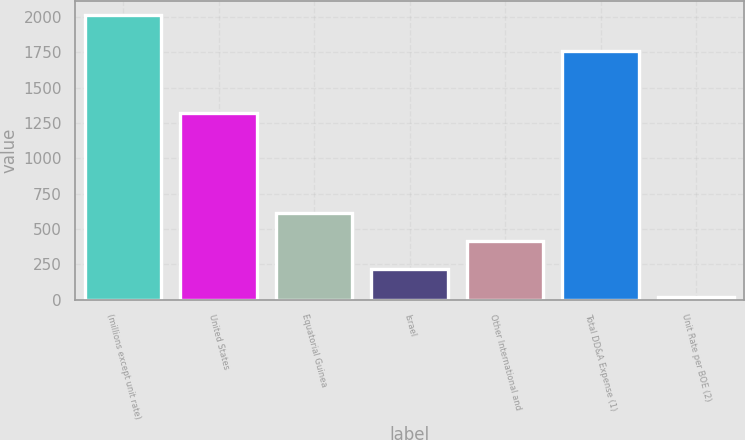<chart> <loc_0><loc_0><loc_500><loc_500><bar_chart><fcel>(millions except unit rate)<fcel>United States<fcel>Equatorial Guinea<fcel>Israel<fcel>Other International and<fcel>Total DD&A Expense (1)<fcel>Unit Rate per BOE (2)<nl><fcel>2014<fcel>1318<fcel>615.8<fcel>216.3<fcel>416.05<fcel>1759<fcel>16.55<nl></chart> 